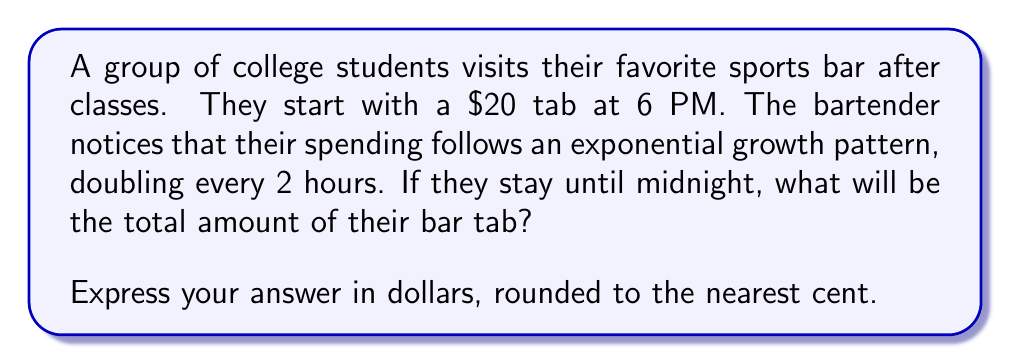Solve this math problem. Let's approach this problem step-by-step:

1) We start with an initial amount of $20 at 6 PM.

2) The amount doubles every 2 hours, which means we have an exponential growth function.

3) The general form of an exponential growth function is:
   
   $$ A(t) = A_0 \cdot (1 + r)^t $$

   Where:
   $A(t)$ is the amount after time $t$
   $A_0$ is the initial amount
   $r$ is the growth rate
   $t$ is the number of time periods

4) In this case:
   $A_0 = 20$
   The growth rate is 100% (doubling) every 2 hours, so $r = 1$
   Time periods are 2-hour intervals

5) From 6 PM to midnight is 6 hours, which is 3 time periods of 2 hours each.

6) Plugging into our formula:

   $$ A(3) = 20 \cdot (1 + 1)^3 $$

7) Simplify:
   $$ A(3) = 20 \cdot 2^3 = 20 \cdot 8 = 160 $$

Therefore, the bar tab will be $160 at midnight.
Answer: $160.00 